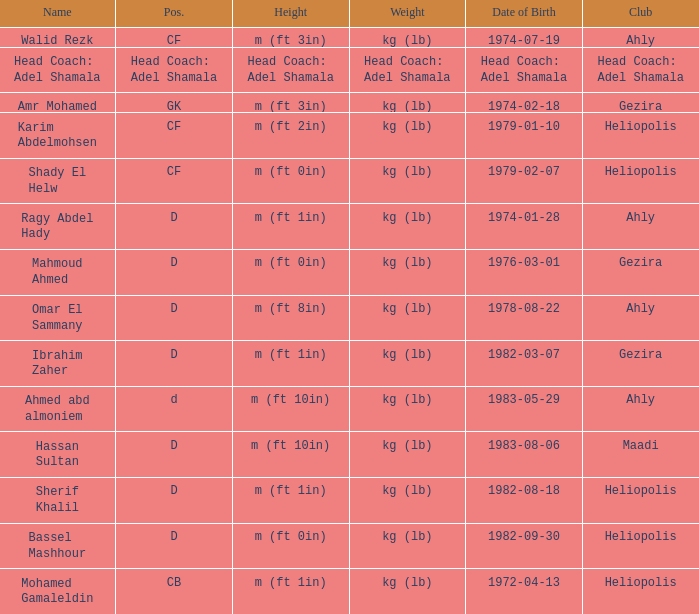What is Weight, when Club is "Ahly", and when Name is "Ragy Abdel Hady"? Kg (lb). 